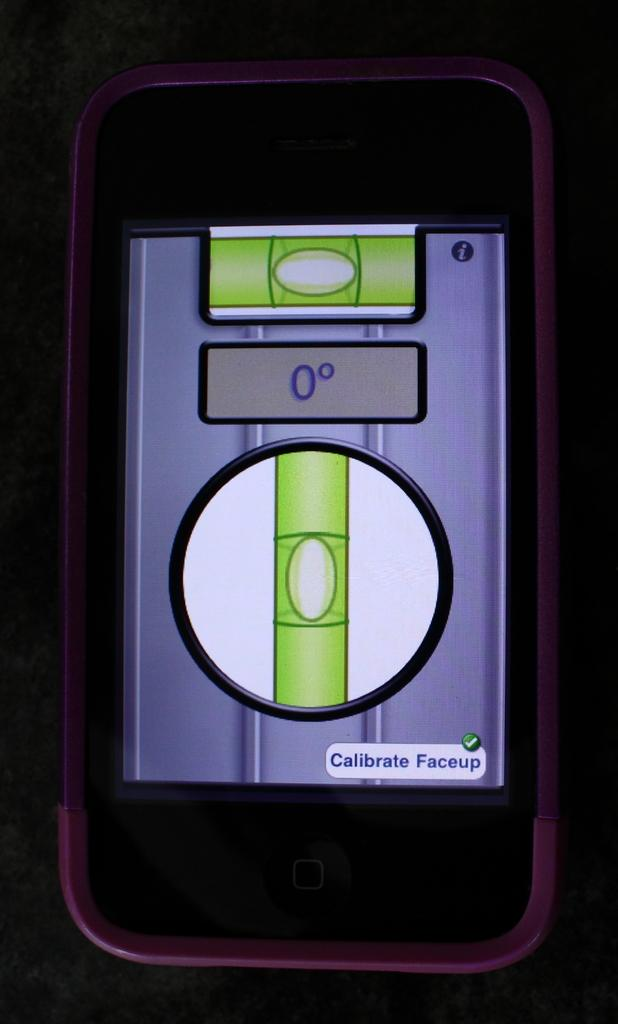<image>
Present a compact description of the photo's key features. A phone with a pink case is calibrating a faceup, and reading at zero degrees. 